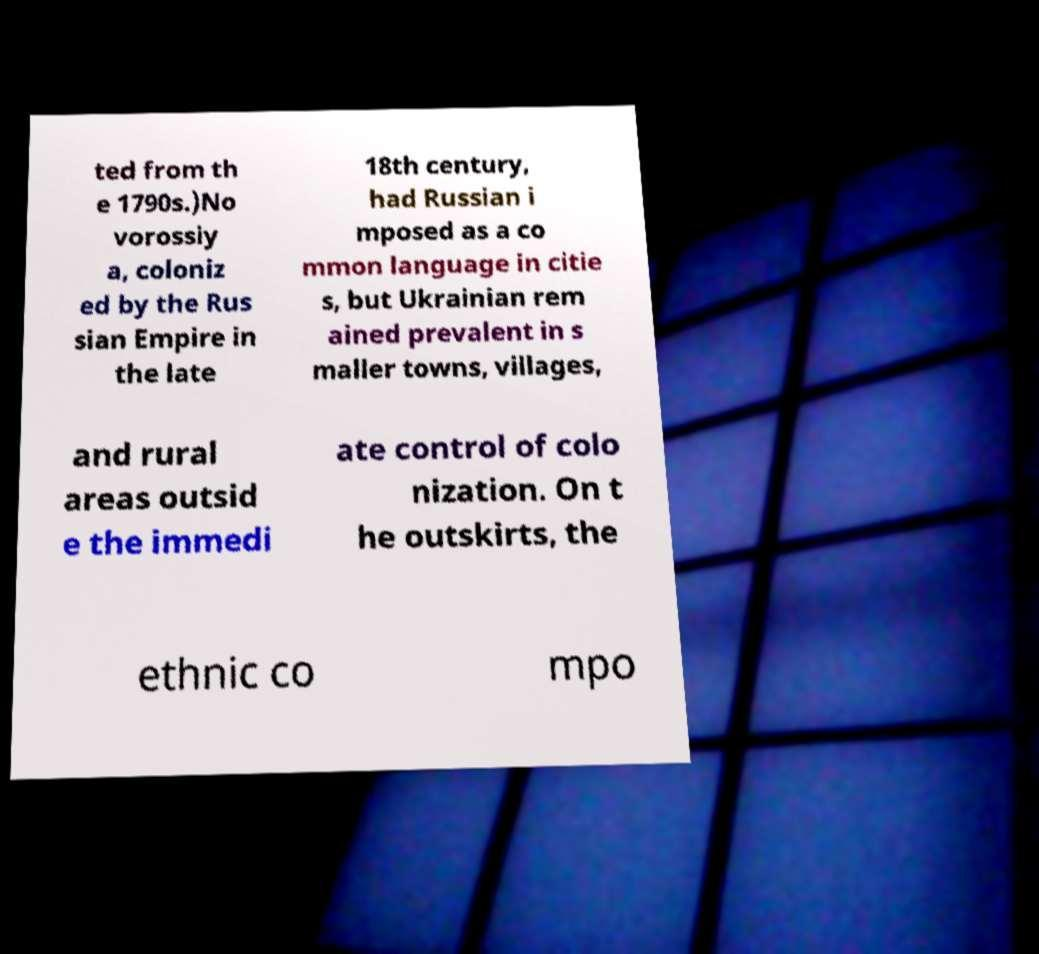For documentation purposes, I need the text within this image transcribed. Could you provide that? ted from th e 1790s.)No vorossiy a, coloniz ed by the Rus sian Empire in the late 18th century, had Russian i mposed as a co mmon language in citie s, but Ukrainian rem ained prevalent in s maller towns, villages, and rural areas outsid e the immedi ate control of colo nization. On t he outskirts, the ethnic co mpo 